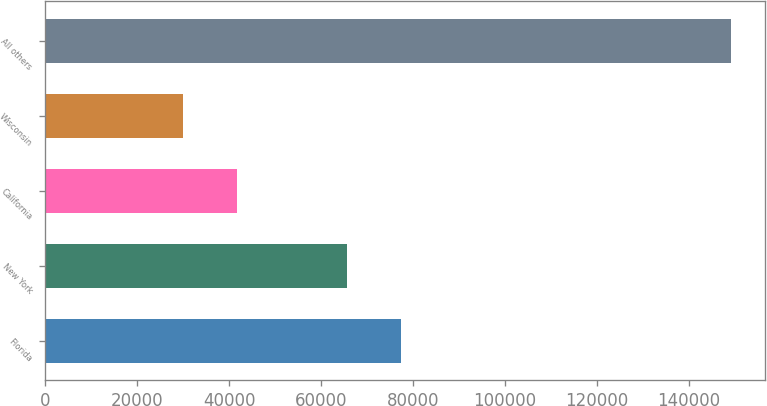Convert chart to OTSL. <chart><loc_0><loc_0><loc_500><loc_500><bar_chart><fcel>Florida<fcel>New York<fcel>California<fcel>Wisconsin<fcel>All others<nl><fcel>77498.2<fcel>65568<fcel>41775.2<fcel>29845<fcel>149147<nl></chart> 